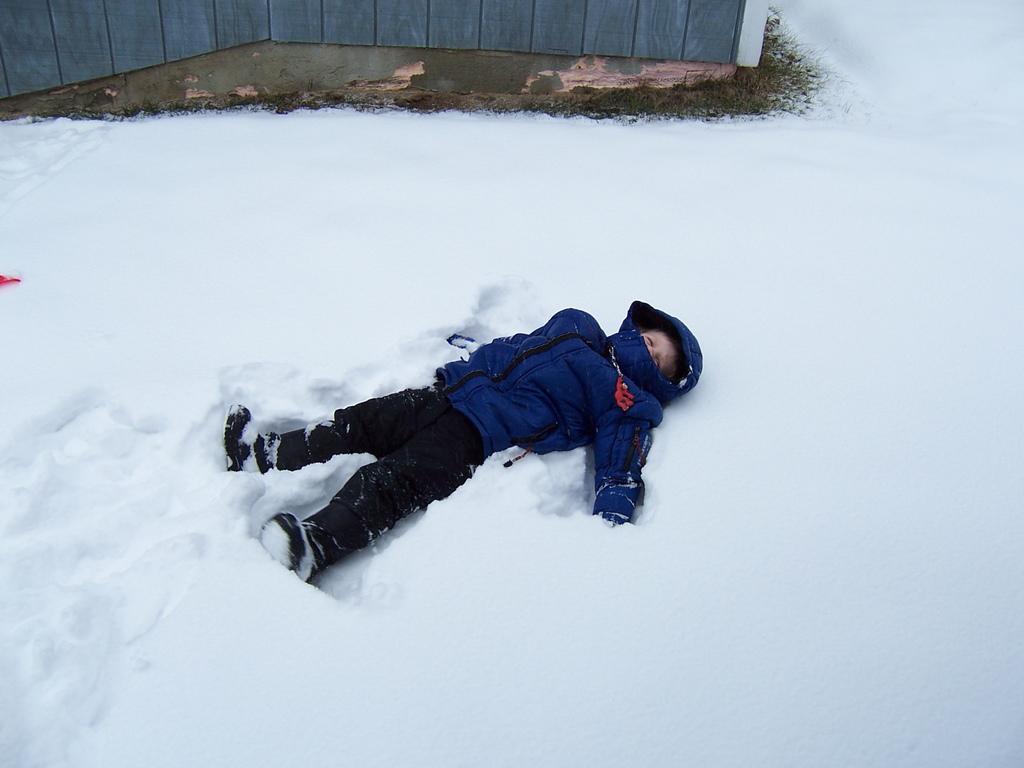How would you summarize this image in a sentence or two? In this image, we can see a kid is lying on the snow. Top of the image, we can see few wooden boards. 